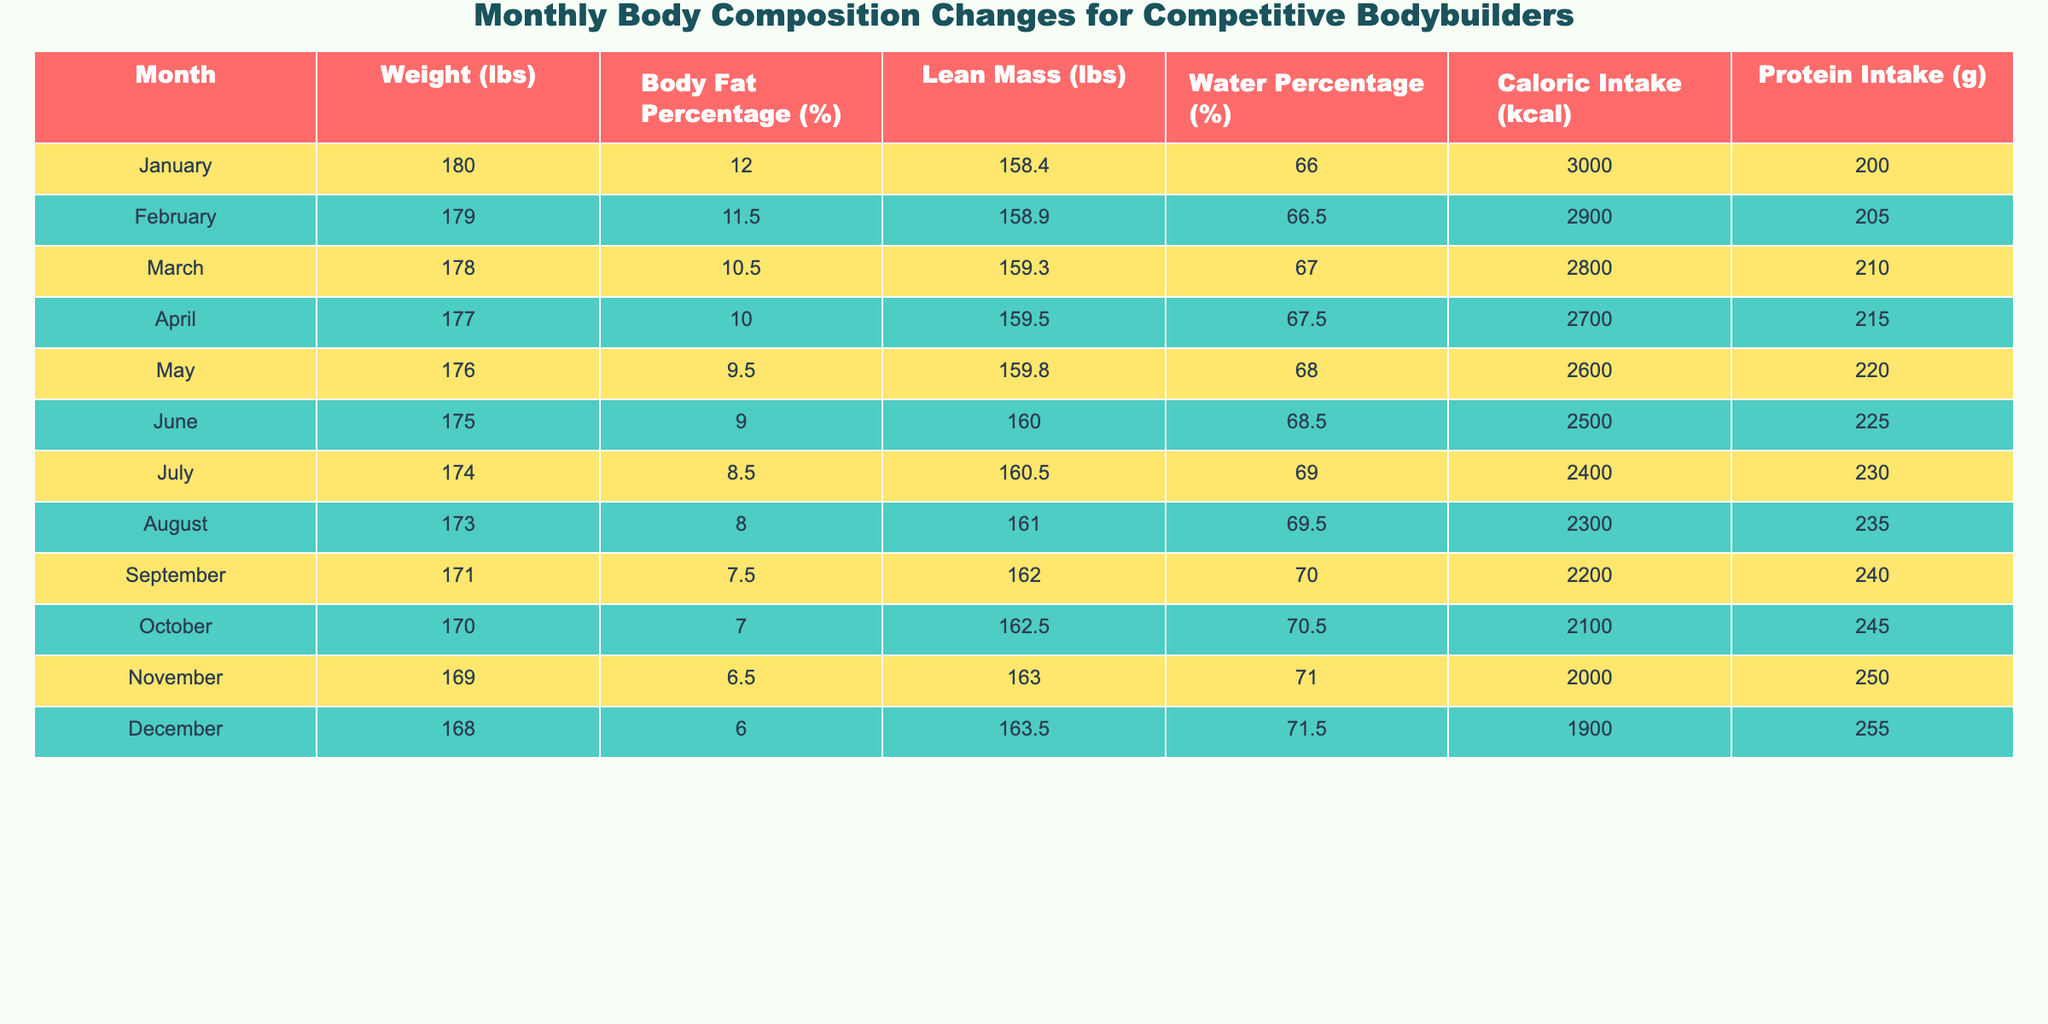What was the weight of the bodybuilder in July? The table shows the entry for July, indicating the weight as 174 lbs.
Answer: 174 lbs What is the body fat percentage in December? From the data, December indicates a body fat percentage of 6.0%.
Answer: 6.0% How much did the lean mass increase from January to November? In January, the lean mass was 158.4 lbs and in November it was 163 lbs. The increase is 163 - 158.4 = 4.6 lbs.
Answer: 4.6 lbs What was the average caloric intake from January to March? First, sum the caloric intake for those months: 3000 (January) + 2900 (February) + 2800 (March) = 8700. Then divide by 3 (the number of months): 8700 / 3 = 2900.
Answer: 2900 Did the water percentage increase from January to October? Looking at the data, the water percentage in January was 66% and in October it was 70.5%. Since 70.5% is greater than 66%, the statement is true.
Answer: Yes What is the total protein intake from March to December? The total protein intake can be found by adding the values for each month from March (210 g) to December (255 g): 210 + 215 + 220 + 225 + 230 + 235 + 240 + 245 + 250 + 255 = 2360 g.
Answer: 2360 g In which month was the bodybuilder's water percentage the highest? Upon reviewing the table, the water percentage was highest in December at 71.5%.
Answer: December How much did the weight decrease from March to June? The weights for March and June are 178 lbs and 175 lbs, respectively. The decrease is 178 - 175 = 3 lbs.
Answer: 3 lbs Is the protein intake consistent in the last three months of the year? By checking the protein intake for the last three months (October: 245 g, November: 250 g, December: 255 g), it's clear that the intake increases each month, so it's not consistent. Therefore, the answer is false.
Answer: No 